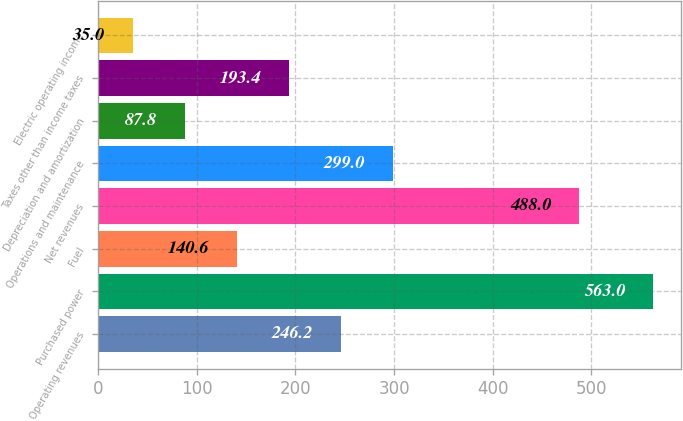Convert chart. <chart><loc_0><loc_0><loc_500><loc_500><bar_chart><fcel>Operating revenues<fcel>Purchased power<fcel>Fuel<fcel>Net revenues<fcel>Operations and maintenance<fcel>Depreciation and amortization<fcel>Taxes other than income taxes<fcel>Electric operating income<nl><fcel>246.2<fcel>563<fcel>140.6<fcel>488<fcel>299<fcel>87.8<fcel>193.4<fcel>35<nl></chart> 